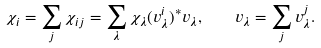Convert formula to latex. <formula><loc_0><loc_0><loc_500><loc_500>\chi _ { i } = \sum _ { j } \chi _ { i j } = \sum _ { \lambda } \chi _ { \lambda } ( v ^ { i } _ { \lambda } ) ^ { * } v _ { \lambda } , \quad v _ { \lambda } = \sum _ { j } v ^ { j } _ { \lambda } .</formula> 